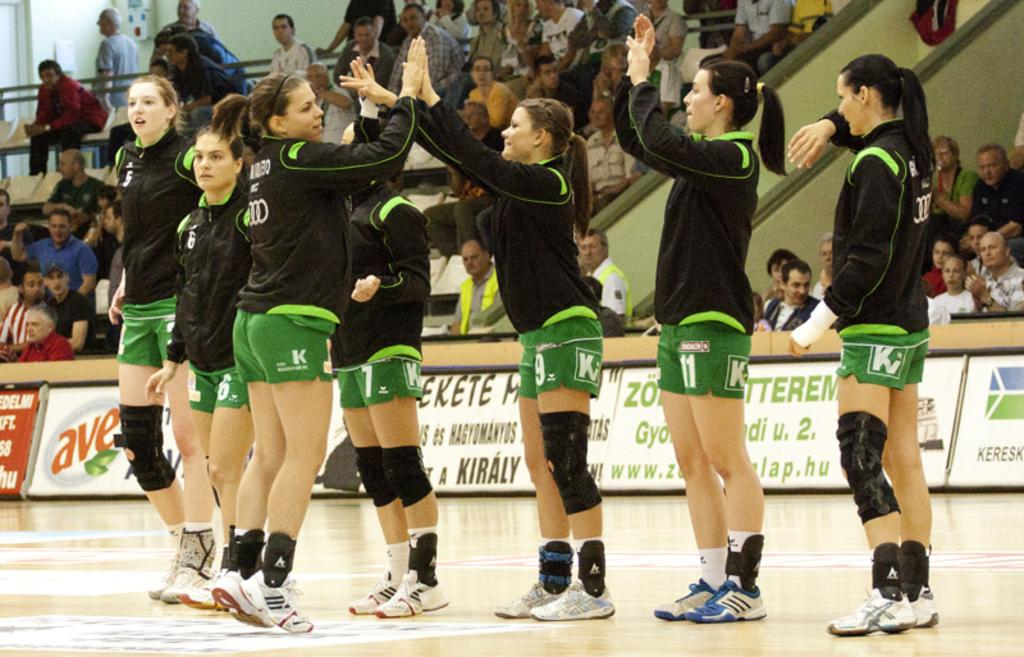Who is present in the image? There are girls in the image. What are the girls wearing? The girls are wearing black jerseys and green shorts. Where are the girls standing? The girls are standing on a play field. What can be observed about the audience members in the image? There are many audience members in the image, and they are sitting on chairs. What are the audience members looking at? The audience members are looking at a game. What type of oven is visible in the image? There is no oven present in the image. What is the air quality like in the image? The provided facts do not give information about the air quality in the image. 